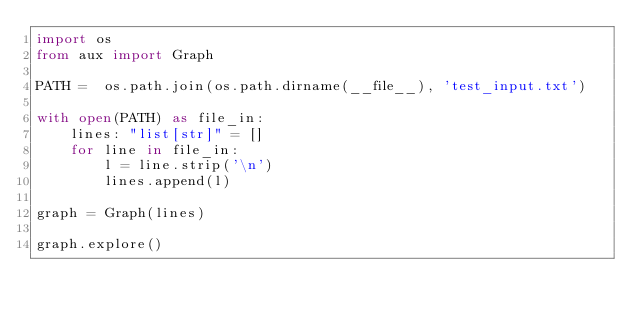Convert code to text. <code><loc_0><loc_0><loc_500><loc_500><_Python_>import os
from aux import Graph

PATH =  os.path.join(os.path.dirname(__file__), 'test_input.txt')

with open(PATH) as file_in:
    lines: "list[str]" = []
    for line in file_in:
        l = line.strip('\n')
        lines.append(l)

graph = Graph(lines)

graph.explore()</code> 